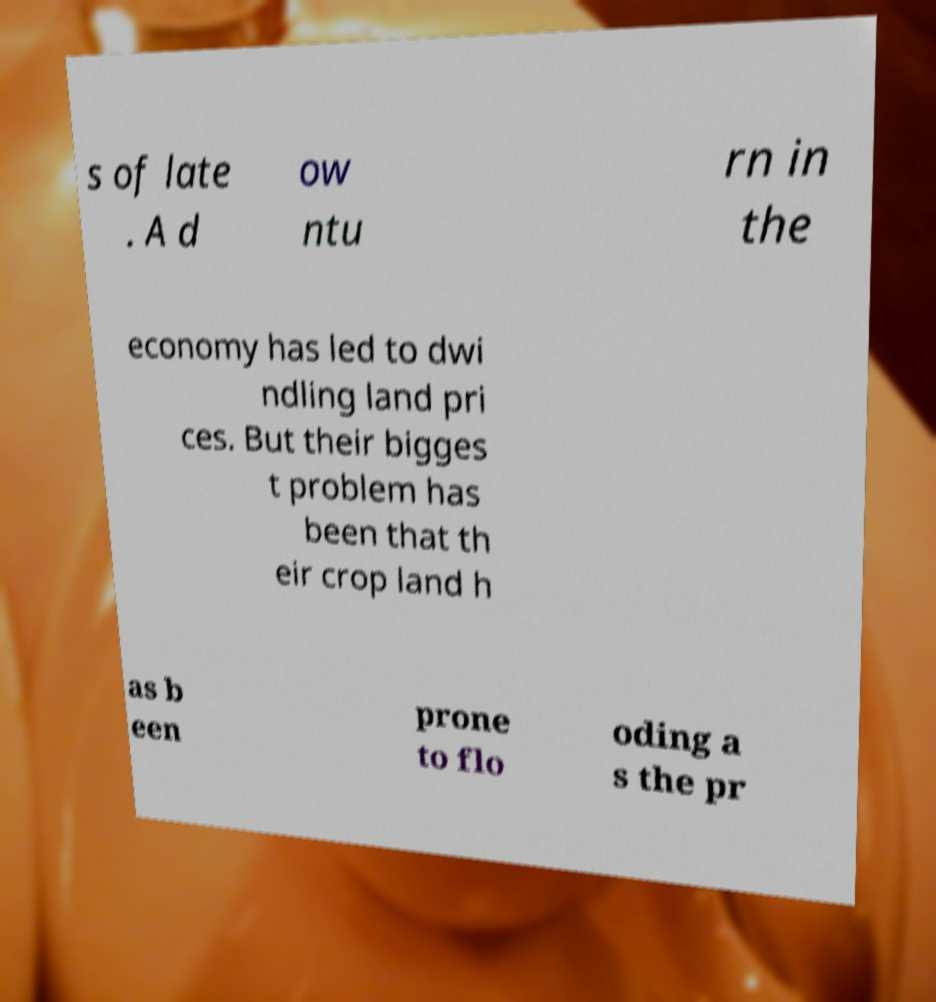I need the written content from this picture converted into text. Can you do that? s of late . A d ow ntu rn in the economy has led to dwi ndling land pri ces. But their bigges t problem has been that th eir crop land h as b een prone to flo oding a s the pr 